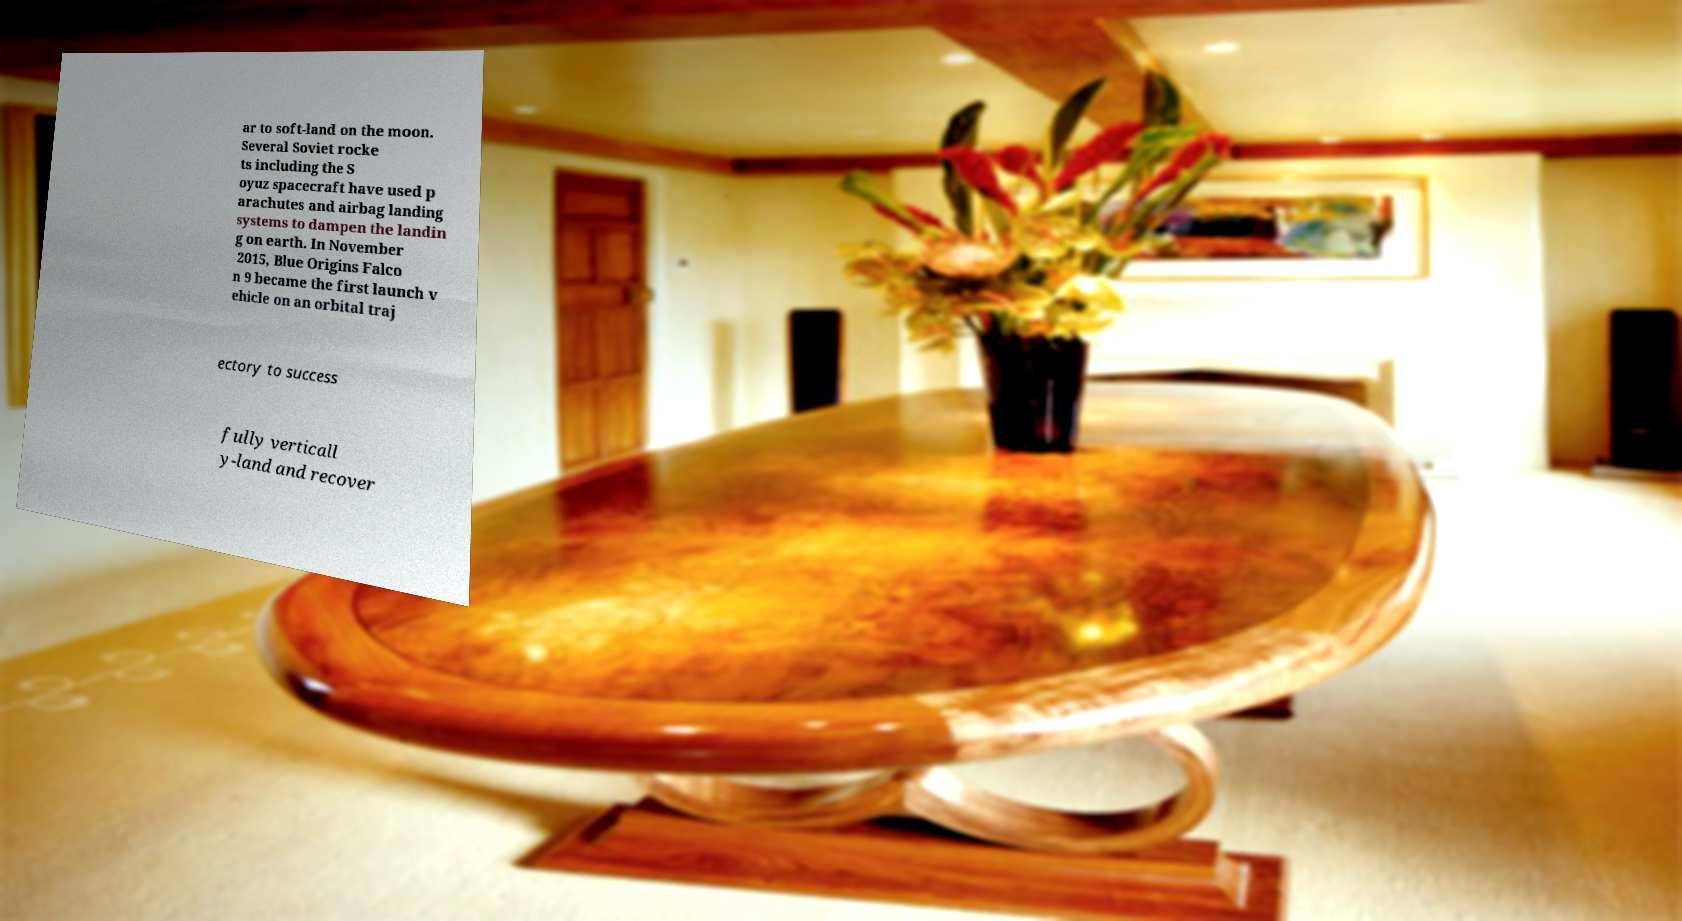There's text embedded in this image that I need extracted. Can you transcribe it verbatim? ar to soft-land on the moon. Several Soviet rocke ts including the S oyuz spacecraft have used p arachutes and airbag landing systems to dampen the landin g on earth. In November 2015, Blue Origins Falco n 9 became the first launch v ehicle on an orbital traj ectory to success fully verticall y-land and recover 